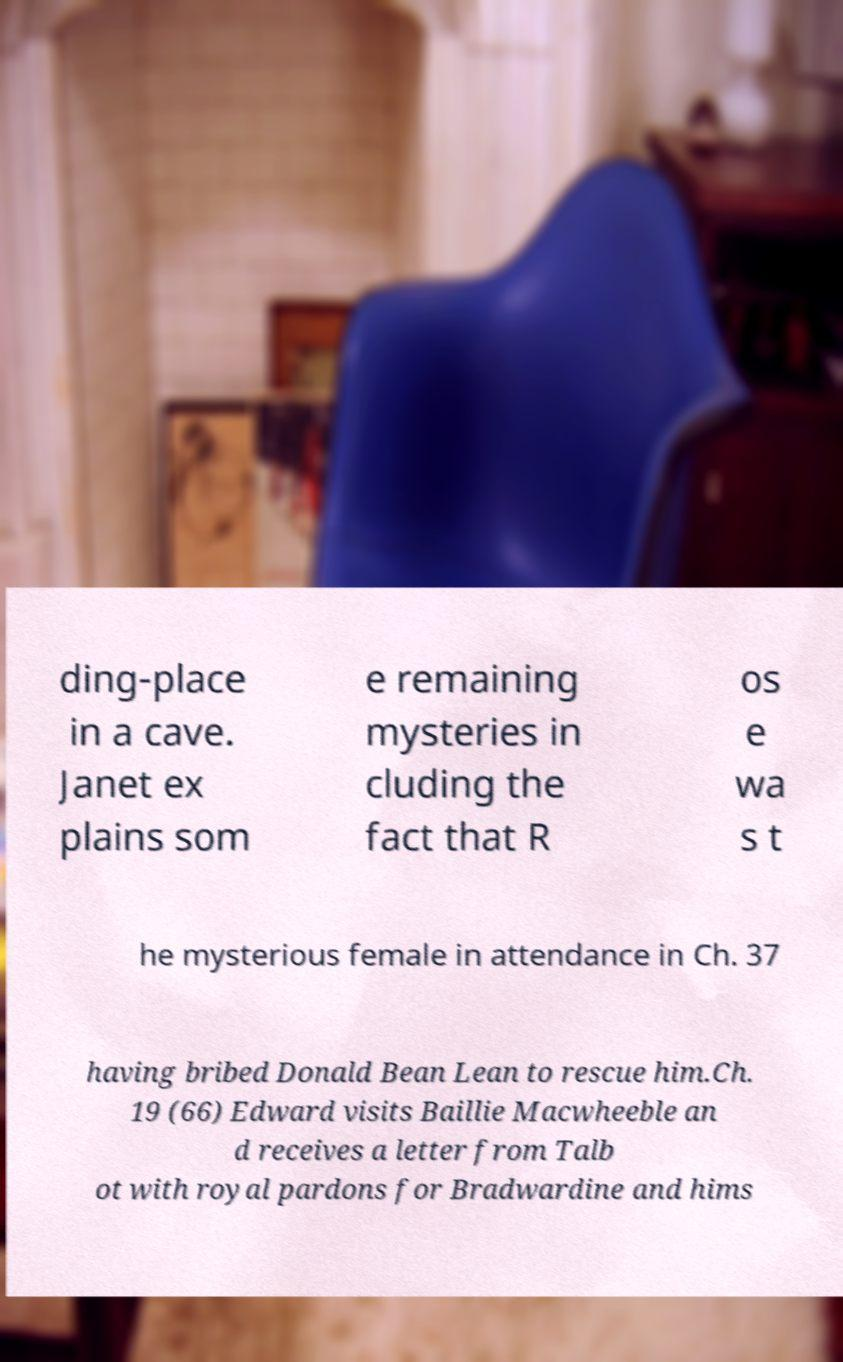I need the written content from this picture converted into text. Can you do that? ding-place in a cave. Janet ex plains som e remaining mysteries in cluding the fact that R os e wa s t he mysterious female in attendance in Ch. 37 having bribed Donald Bean Lean to rescue him.Ch. 19 (66) Edward visits Baillie Macwheeble an d receives a letter from Talb ot with royal pardons for Bradwardine and hims 